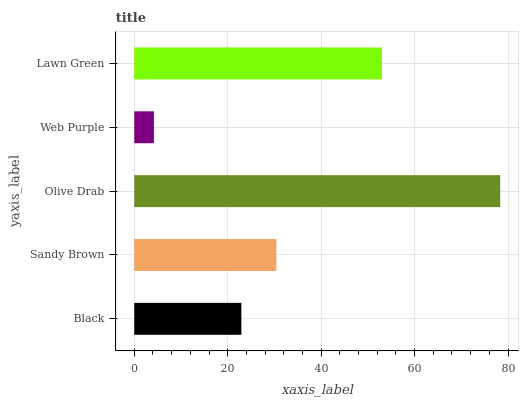Is Web Purple the minimum?
Answer yes or no. Yes. Is Olive Drab the maximum?
Answer yes or no. Yes. Is Sandy Brown the minimum?
Answer yes or no. No. Is Sandy Brown the maximum?
Answer yes or no. No. Is Sandy Brown greater than Black?
Answer yes or no. Yes. Is Black less than Sandy Brown?
Answer yes or no. Yes. Is Black greater than Sandy Brown?
Answer yes or no. No. Is Sandy Brown less than Black?
Answer yes or no. No. Is Sandy Brown the high median?
Answer yes or no. Yes. Is Sandy Brown the low median?
Answer yes or no. Yes. Is Web Purple the high median?
Answer yes or no. No. Is Web Purple the low median?
Answer yes or no. No. 